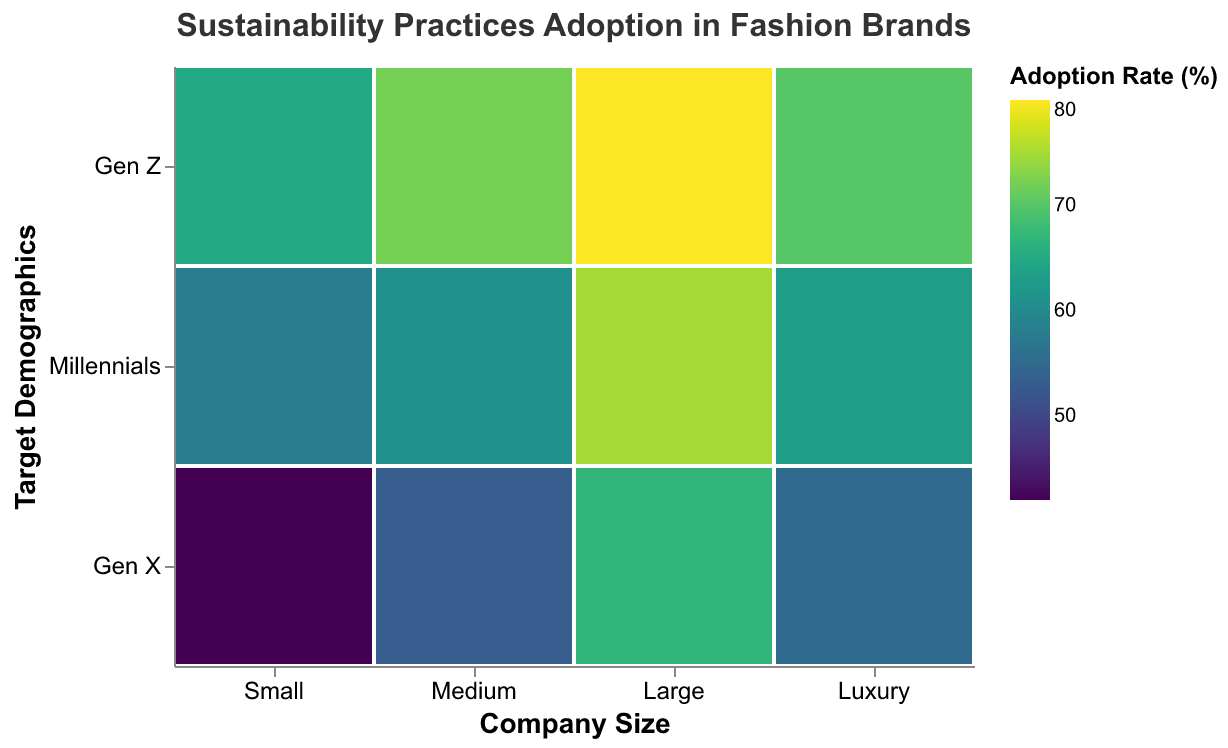What is the title of the figure? The title is located at the top of the figure in a larger font size. It is displayed clearly and concisely to describe the content of the plot.
Answer: Sustainability Practices Adoption in Fashion Brands Which company size has the highest adoption rate for the practice 'Zero Waste'? To find this, look at the adoption rate for 'Zero Waste' across all company sizes. The highest adoption rate is 80%, which corresponds to the 'Large' company size.
Answer: Large What is the adoption rate for 'Circular Fashion' in Medium companies? Locate the Medium column, then find the row for Millennials, and check the color legend.
Answer: 61% Compare the adoption rates of 'Vegan Materials' and 'Recycled Materials' for Gen Z demographics. Which one is higher? Locate the values for 'Vegan Materials' under 'Luxury' and 'Recycled Materials' under 'Small'. Compare their adoption rates. Vegan Materials is 70%, and Recycled Materials is 65%.
Answer: Vegan Materials What are the different sustainability practices adopted by Small companies? By looking at the 'Small' column, we can see that 'Recycled Materials,' 'Ethical Labor,' and 'Organic Fabrics' are adopted.
Answer: Recycled Materials, Ethical Labor, Organic Fabrics Calculate the average adoption rate for all sustainability practices adopted by Gen Z demographics. Find the adoption rates for Gen Z across all company sizes: 65, 72, 80, 70. Average is calculated by (65+72+80+70)/4.
Answer: 71.75 Which target demographics have the highest adoption rate for Large companies, and what practice does it relate to? Find the highest rate in the 'Large' column, which is 80%, corresponding to Gen Z with 'Zero Waste.'
Answer: Gen Z, Zero Waste Is the adoption rate for 'Sustainable Packaging' higher in Large companies compared to 'Water Conservation' in Medium companies? Check the figures for 'Sustainable Packaging' in Large companies (75%) and 'Water Conservation' in Medium companies (53%). 75% is higher than 53%.
Answer: Yes How does the adoption rate for 'Eco-friendly Dyes' in Large companies compare to 'Slow Fashion' in Luxury companies? Compare the adoption rates: 67% for 'Eco-friendly Dyes' in Large companies and 55% for 'Slow Fashion' in Luxury companies. 67% is higher than 55%.
Answer: Eco-friendly Dyes is higher Which company size has the lowest adoption rate for any sustainability practice, and what is that sustainability practice? Look for the smallest number across all cells in the plot. The lowest is 42% for 'Organic Fabrics' under Small companies.
Answer: Small, Organic Fabrics 